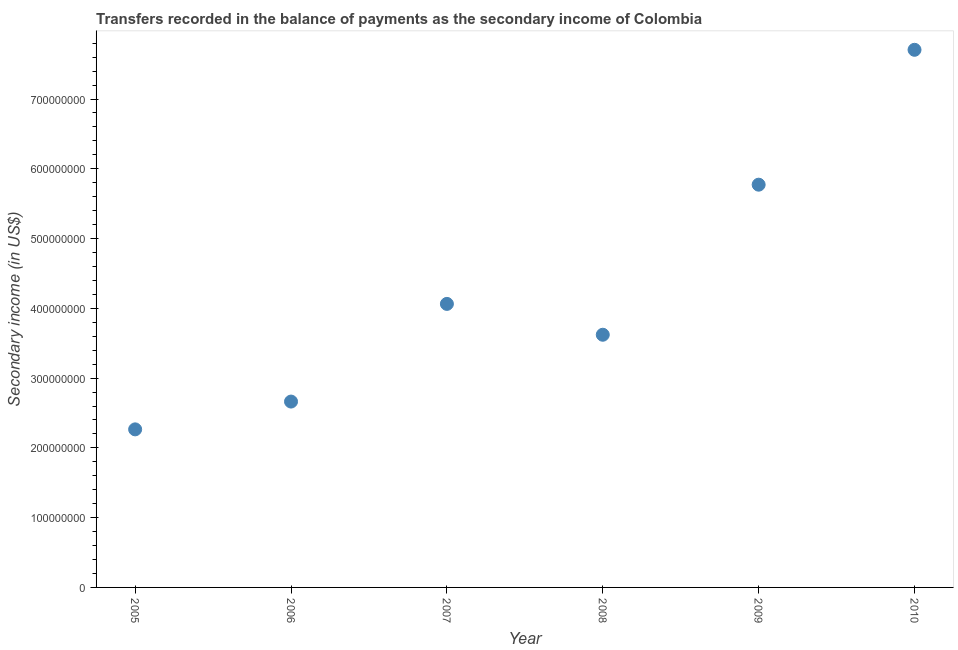What is the amount of secondary income in 2006?
Offer a very short reply. 2.66e+08. Across all years, what is the maximum amount of secondary income?
Provide a short and direct response. 7.71e+08. Across all years, what is the minimum amount of secondary income?
Ensure brevity in your answer.  2.27e+08. What is the sum of the amount of secondary income?
Make the answer very short. 2.61e+09. What is the difference between the amount of secondary income in 2005 and 2008?
Your answer should be very brief. -1.36e+08. What is the average amount of secondary income per year?
Your answer should be very brief. 4.35e+08. What is the median amount of secondary income?
Provide a succinct answer. 3.84e+08. Do a majority of the years between 2010 and 2008 (inclusive) have amount of secondary income greater than 480000000 US$?
Your answer should be very brief. No. What is the ratio of the amount of secondary income in 2007 to that in 2008?
Provide a succinct answer. 1.12. Is the amount of secondary income in 2006 less than that in 2007?
Offer a terse response. Yes. What is the difference between the highest and the second highest amount of secondary income?
Keep it short and to the point. 1.93e+08. What is the difference between the highest and the lowest amount of secondary income?
Ensure brevity in your answer.  5.44e+08. How many dotlines are there?
Provide a succinct answer. 1. How many years are there in the graph?
Your response must be concise. 6. Does the graph contain any zero values?
Provide a succinct answer. No. What is the title of the graph?
Keep it short and to the point. Transfers recorded in the balance of payments as the secondary income of Colombia. What is the label or title of the X-axis?
Make the answer very short. Year. What is the label or title of the Y-axis?
Provide a short and direct response. Secondary income (in US$). What is the Secondary income (in US$) in 2005?
Ensure brevity in your answer.  2.27e+08. What is the Secondary income (in US$) in 2006?
Offer a very short reply. 2.66e+08. What is the Secondary income (in US$) in 2007?
Keep it short and to the point. 4.06e+08. What is the Secondary income (in US$) in 2008?
Your response must be concise. 3.62e+08. What is the Secondary income (in US$) in 2009?
Make the answer very short. 5.77e+08. What is the Secondary income (in US$) in 2010?
Give a very brief answer. 7.71e+08. What is the difference between the Secondary income (in US$) in 2005 and 2006?
Make the answer very short. -3.98e+07. What is the difference between the Secondary income (in US$) in 2005 and 2007?
Your response must be concise. -1.80e+08. What is the difference between the Secondary income (in US$) in 2005 and 2008?
Offer a very short reply. -1.36e+08. What is the difference between the Secondary income (in US$) in 2005 and 2009?
Keep it short and to the point. -3.51e+08. What is the difference between the Secondary income (in US$) in 2005 and 2010?
Make the answer very short. -5.44e+08. What is the difference between the Secondary income (in US$) in 2006 and 2007?
Ensure brevity in your answer.  -1.40e+08. What is the difference between the Secondary income (in US$) in 2006 and 2008?
Ensure brevity in your answer.  -9.58e+07. What is the difference between the Secondary income (in US$) in 2006 and 2009?
Offer a terse response. -3.11e+08. What is the difference between the Secondary income (in US$) in 2006 and 2010?
Your response must be concise. -5.04e+08. What is the difference between the Secondary income (in US$) in 2007 and 2008?
Ensure brevity in your answer.  4.42e+07. What is the difference between the Secondary income (in US$) in 2007 and 2009?
Provide a short and direct response. -1.71e+08. What is the difference between the Secondary income (in US$) in 2007 and 2010?
Provide a succinct answer. -3.64e+08. What is the difference between the Secondary income (in US$) in 2008 and 2009?
Offer a very short reply. -2.15e+08. What is the difference between the Secondary income (in US$) in 2008 and 2010?
Give a very brief answer. -4.08e+08. What is the difference between the Secondary income (in US$) in 2009 and 2010?
Your answer should be very brief. -1.93e+08. What is the ratio of the Secondary income (in US$) in 2005 to that in 2006?
Your response must be concise. 0.85. What is the ratio of the Secondary income (in US$) in 2005 to that in 2007?
Make the answer very short. 0.56. What is the ratio of the Secondary income (in US$) in 2005 to that in 2008?
Offer a terse response. 0.63. What is the ratio of the Secondary income (in US$) in 2005 to that in 2009?
Provide a succinct answer. 0.39. What is the ratio of the Secondary income (in US$) in 2005 to that in 2010?
Make the answer very short. 0.29. What is the ratio of the Secondary income (in US$) in 2006 to that in 2007?
Offer a very short reply. 0.66. What is the ratio of the Secondary income (in US$) in 2006 to that in 2008?
Offer a terse response. 0.74. What is the ratio of the Secondary income (in US$) in 2006 to that in 2009?
Ensure brevity in your answer.  0.46. What is the ratio of the Secondary income (in US$) in 2006 to that in 2010?
Offer a terse response. 0.35. What is the ratio of the Secondary income (in US$) in 2007 to that in 2008?
Offer a terse response. 1.12. What is the ratio of the Secondary income (in US$) in 2007 to that in 2009?
Provide a succinct answer. 0.7. What is the ratio of the Secondary income (in US$) in 2007 to that in 2010?
Your response must be concise. 0.53. What is the ratio of the Secondary income (in US$) in 2008 to that in 2009?
Offer a very short reply. 0.63. What is the ratio of the Secondary income (in US$) in 2008 to that in 2010?
Your answer should be very brief. 0.47. What is the ratio of the Secondary income (in US$) in 2009 to that in 2010?
Your answer should be very brief. 0.75. 